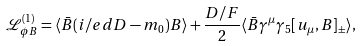Convert formula to latex. <formula><loc_0><loc_0><loc_500><loc_500>\mathcal { L } _ { \phi B } ^ { ( 1 ) } = \langle \bar { B } ( i \slash e d D - m _ { 0 } ) B \rangle + \frac { D / F } { 2 } \langle \bar { B } \gamma ^ { \mu } \gamma _ { 5 } [ u _ { \mu } , B ] _ { \pm } \rangle ,</formula> 